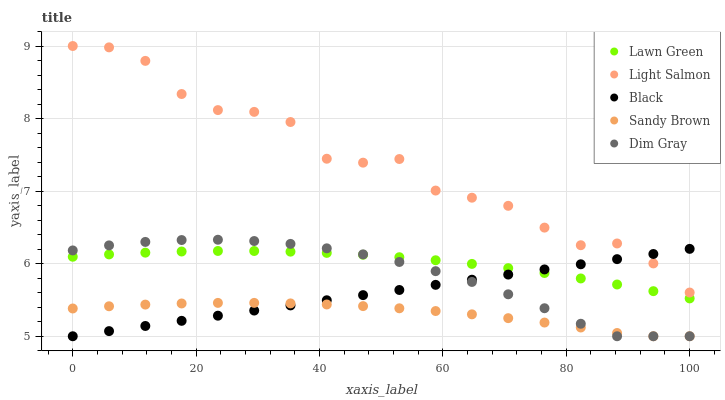Does Sandy Brown have the minimum area under the curve?
Answer yes or no. Yes. Does Light Salmon have the maximum area under the curve?
Answer yes or no. Yes. Does Dim Gray have the minimum area under the curve?
Answer yes or no. No. Does Dim Gray have the maximum area under the curve?
Answer yes or no. No. Is Black the smoothest?
Answer yes or no. Yes. Is Light Salmon the roughest?
Answer yes or no. Yes. Is Dim Gray the smoothest?
Answer yes or no. No. Is Dim Gray the roughest?
Answer yes or no. No. Does Dim Gray have the lowest value?
Answer yes or no. Yes. Does Light Salmon have the lowest value?
Answer yes or no. No. Does Light Salmon have the highest value?
Answer yes or no. Yes. Does Dim Gray have the highest value?
Answer yes or no. No. Is Sandy Brown less than Lawn Green?
Answer yes or no. Yes. Is Light Salmon greater than Sandy Brown?
Answer yes or no. Yes. Does Dim Gray intersect Sandy Brown?
Answer yes or no. Yes. Is Dim Gray less than Sandy Brown?
Answer yes or no. No. Is Dim Gray greater than Sandy Brown?
Answer yes or no. No. Does Sandy Brown intersect Lawn Green?
Answer yes or no. No. 